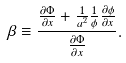<formula> <loc_0><loc_0><loc_500><loc_500>\beta \equiv \frac { \frac { \partial \Phi } { \partial x } + \frac { 1 } { a ^ { 2 } } \frac { 1 } { \phi } \frac { \partial \phi } { \partial x } } { \frac { \partial \Phi } { \partial x } } .</formula> 